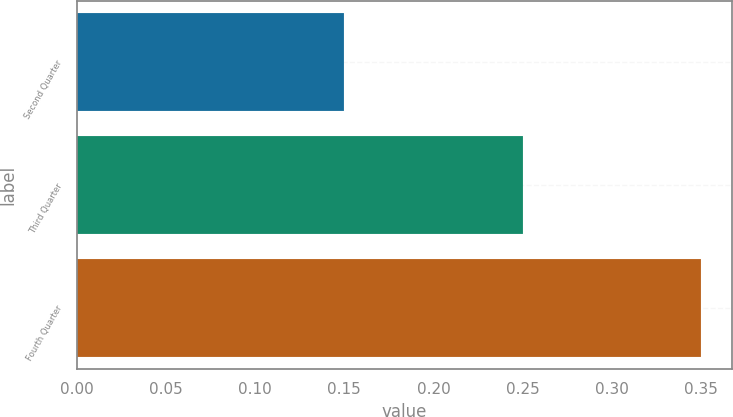<chart> <loc_0><loc_0><loc_500><loc_500><bar_chart><fcel>Second Quarter<fcel>Third Quarter<fcel>Fourth Quarter<nl><fcel>0.15<fcel>0.25<fcel>0.35<nl></chart> 